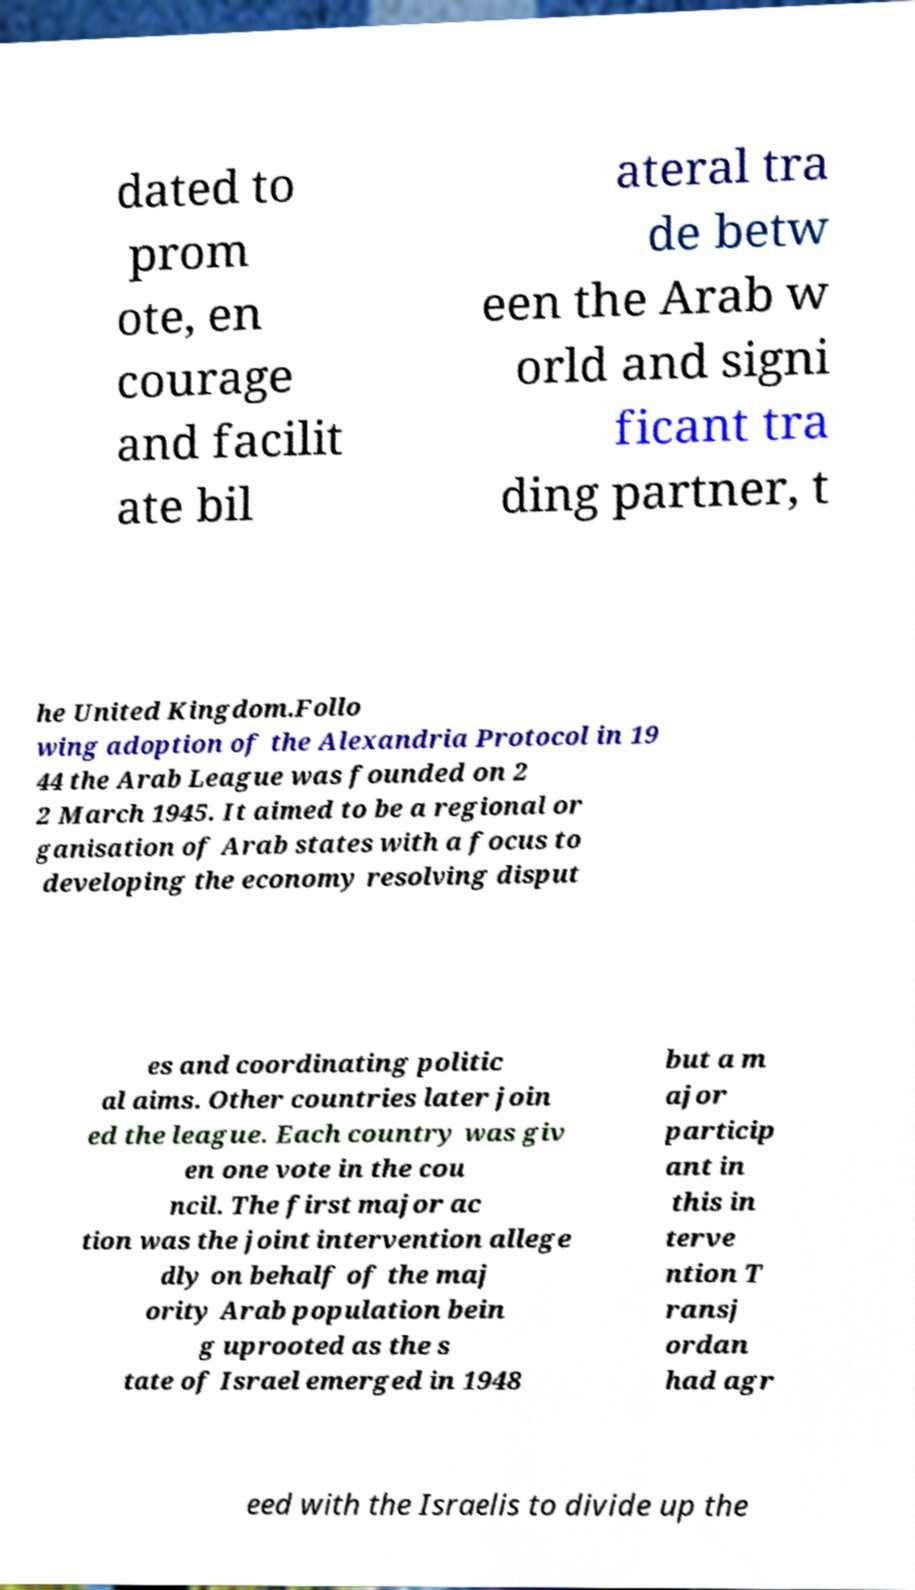I need the written content from this picture converted into text. Can you do that? dated to prom ote, en courage and facilit ate bil ateral tra de betw een the Arab w orld and signi ficant tra ding partner, t he United Kingdom.Follo wing adoption of the Alexandria Protocol in 19 44 the Arab League was founded on 2 2 March 1945. It aimed to be a regional or ganisation of Arab states with a focus to developing the economy resolving disput es and coordinating politic al aims. Other countries later join ed the league. Each country was giv en one vote in the cou ncil. The first major ac tion was the joint intervention allege dly on behalf of the maj ority Arab population bein g uprooted as the s tate of Israel emerged in 1948 but a m ajor particip ant in this in terve ntion T ransj ordan had agr eed with the Israelis to divide up the 